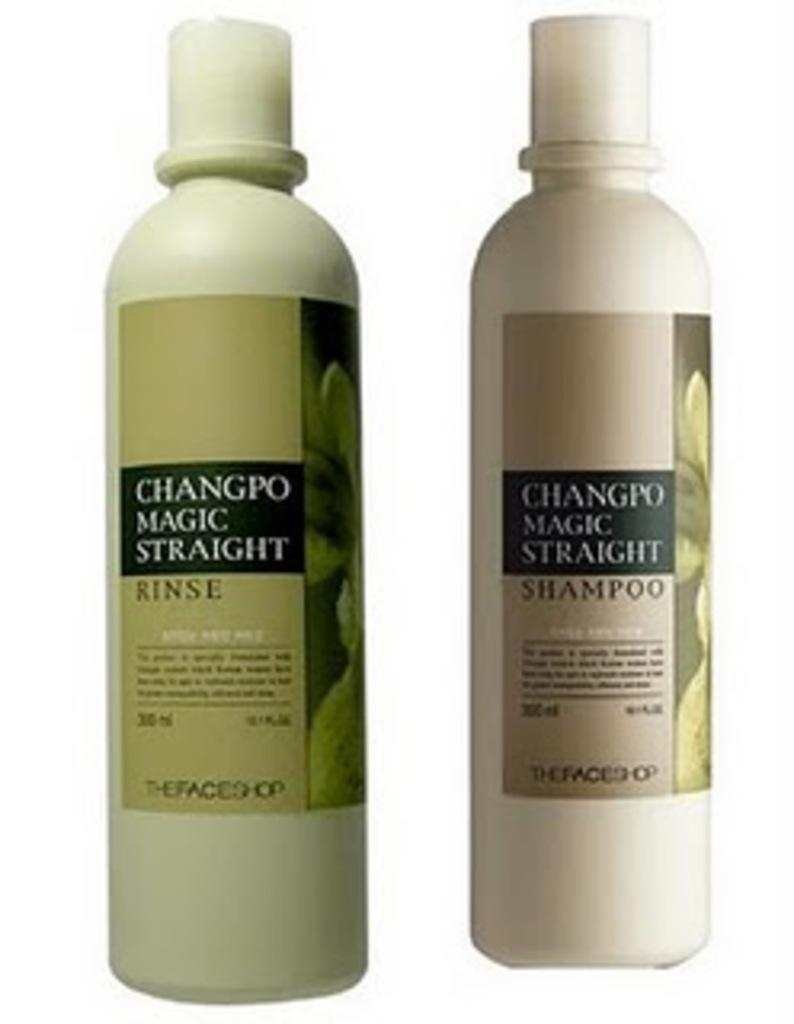<image>
Describe the image concisely. two bottles of Changpo Magic Straight Rinse and Shampoo 